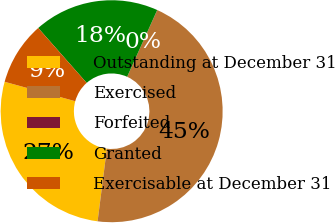Convert chart. <chart><loc_0><loc_0><loc_500><loc_500><pie_chart><fcel>Outstanding at December 31<fcel>Exercised<fcel>Forfeited<fcel>Granted<fcel>Exercisable at December 31<nl><fcel>27.25%<fcel>45.28%<fcel>0.01%<fcel>18.24%<fcel>9.22%<nl></chart> 